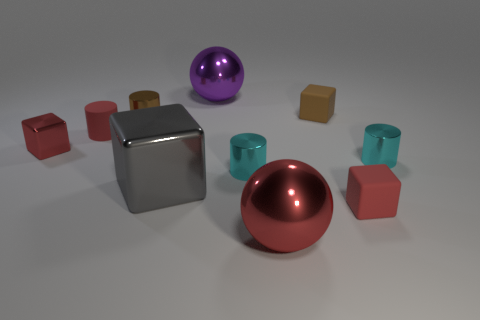Is the tiny rubber cylinder the same color as the small shiny block?
Provide a succinct answer. Yes. There is a object that is both to the left of the brown block and in front of the gray block; what size is it?
Offer a very short reply. Large. Is the number of large shiny objects less than the number of gray metal blocks?
Your answer should be very brief. No. What size is the red shiny object that is in front of the big gray metal cube?
Keep it short and to the point. Large. There is a object that is behind the brown cylinder and to the left of the brown cube; what shape is it?
Your answer should be compact. Sphere. There is a red thing that is the same shape as the purple object; what is its size?
Provide a succinct answer. Large. How many purple things have the same material as the large gray block?
Your response must be concise. 1. Do the rubber cylinder and the small thing that is in front of the large gray object have the same color?
Your answer should be very brief. Yes. Is the number of gray matte cylinders greater than the number of red rubber blocks?
Provide a succinct answer. No. What color is the tiny matte cylinder?
Make the answer very short. Red. 